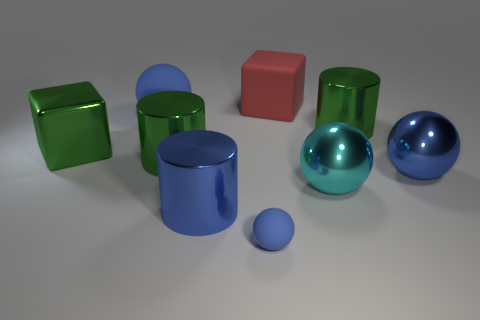Does the tiny thing have the same shape as the large red rubber object?
Offer a terse response. No. What number of other objects are there of the same shape as the small blue thing?
Offer a very short reply. 3. There is a cube that is the same size as the red matte object; what is its color?
Keep it short and to the point. Green. Are there an equal number of big cyan spheres that are behind the big red matte block and big shiny things?
Keep it short and to the point. No. What shape is the large metal thing that is behind the big blue metallic ball and on the right side of the small matte thing?
Provide a short and direct response. Cylinder. Is the size of the cyan metal object the same as the green block?
Keep it short and to the point. Yes. Are there any tiny blue objects that have the same material as the big red thing?
Your answer should be compact. Yes. The matte thing that is the same color as the large rubber sphere is what size?
Your response must be concise. Small. What number of large objects are both to the left of the large rubber cube and behind the large green metal block?
Offer a terse response. 1. What is the large cylinder that is right of the tiny object made of?
Keep it short and to the point. Metal. 